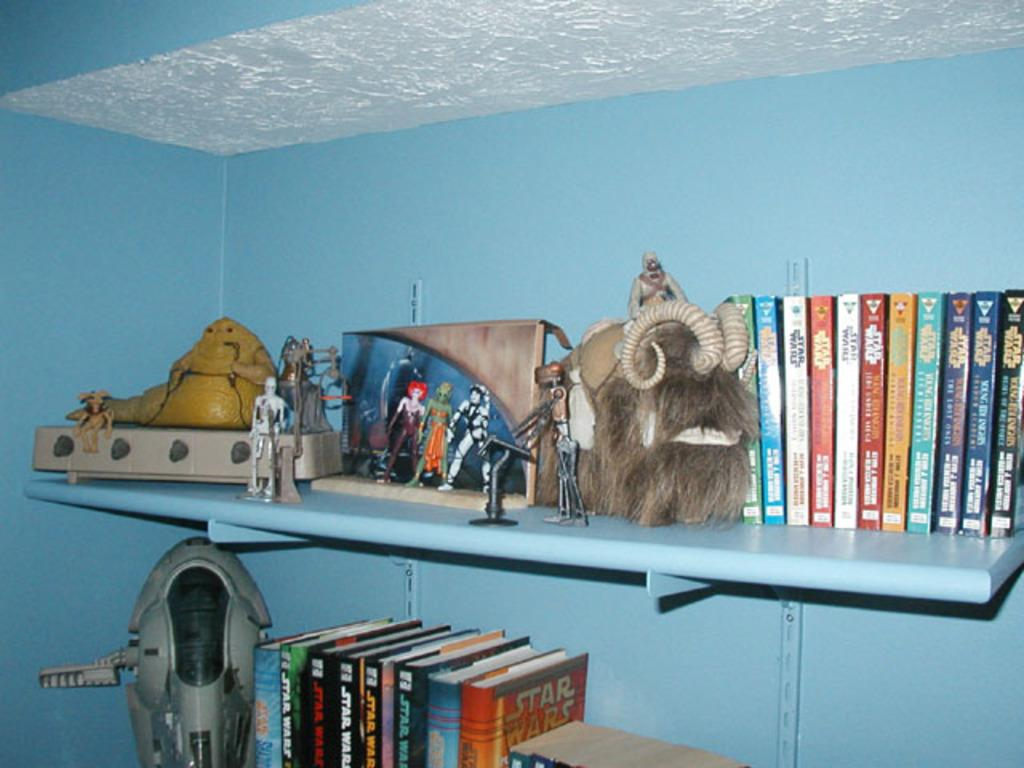What type of object can be seen in the image? There is a mask in the image. What else can be found in the image besides the mask? There are books, toys, and objects in the racks visible in the image. What is the background of the image? There is a wall behind the racks in the image. Where is the nest located in the image? There is no nest present in the image. What type of light can be seen in the image? There is no specific light source mentioned or visible in the image. 